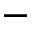Convert formula to latex. <formula><loc_0><loc_0><loc_500><loc_500>-</formula> 